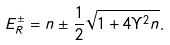Convert formula to latex. <formula><loc_0><loc_0><loc_500><loc_500>E _ { R } ^ { \pm } = n \pm \frac { 1 } { 2 } \sqrt { 1 + 4 \Upsilon ^ { 2 } n } .</formula> 